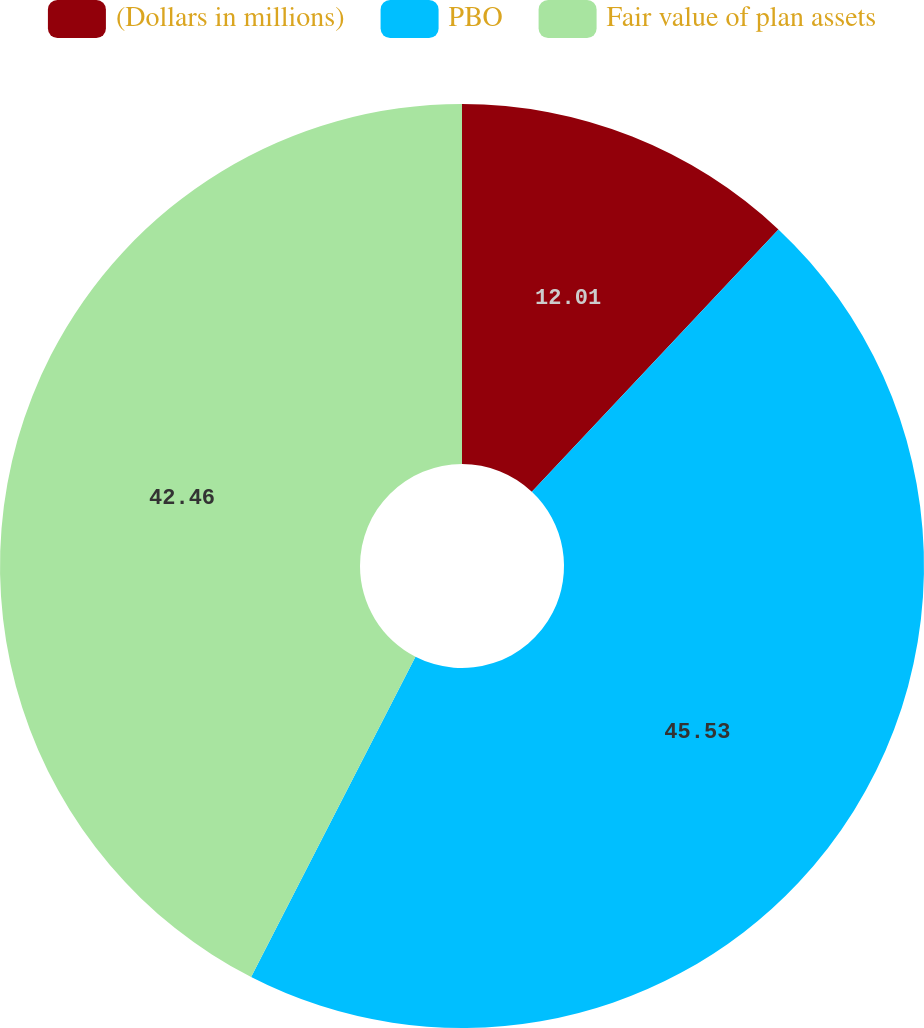Convert chart to OTSL. <chart><loc_0><loc_0><loc_500><loc_500><pie_chart><fcel>(Dollars in millions)<fcel>PBO<fcel>Fair value of plan assets<nl><fcel>12.01%<fcel>45.54%<fcel>42.46%<nl></chart> 